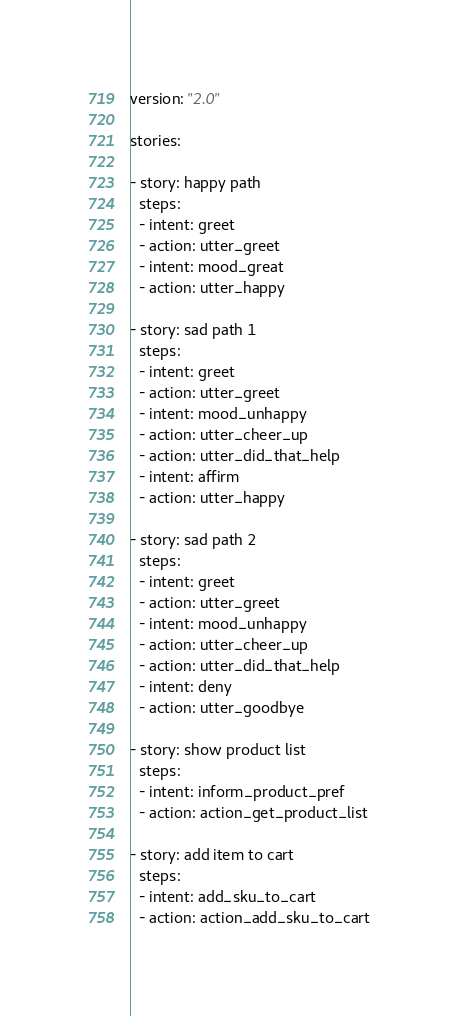<code> <loc_0><loc_0><loc_500><loc_500><_YAML_>version: "2.0"

stories:

- story: happy path
  steps:
  - intent: greet
  - action: utter_greet
  - intent: mood_great
  - action: utter_happy

- story: sad path 1
  steps:
  - intent: greet
  - action: utter_greet
  - intent: mood_unhappy
  - action: utter_cheer_up
  - action: utter_did_that_help
  - intent: affirm
  - action: utter_happy

- story: sad path 2
  steps:
  - intent: greet
  - action: utter_greet
  - intent: mood_unhappy
  - action: utter_cheer_up
  - action: utter_did_that_help
  - intent: deny
  - action: utter_goodbye

- story: show product list
  steps:
  - intent: inform_product_pref
  - action: action_get_product_list

- story: add item to cart
  steps:
  - intent: add_sku_to_cart
  - action: action_add_sku_to_cart</code> 